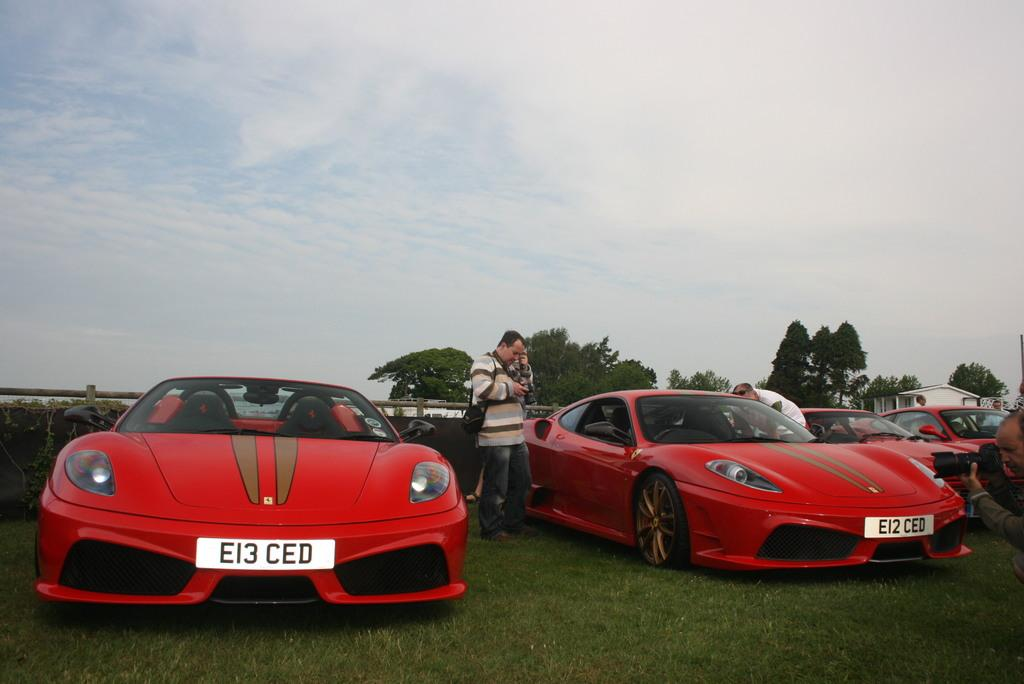What type of vehicles are in the foreground of the image? There are red color cars in the foreground of the image. Where are the cars located? The cars are on the grass. What can be seen beside the cars? There are persons standing beside the cars. What is visible in the background of the image? There is a railing, trees, and the sky visible in the background of the image. What is the condition of the sky in the image? The sky is visible in the background of the image, and there are clouds present. What type of steel is used to construct the burn in the image? There is no burn or steel present in the image; it features red color cars on the grass with persons standing beside them, and a background with a railing, trees, and the sky. 